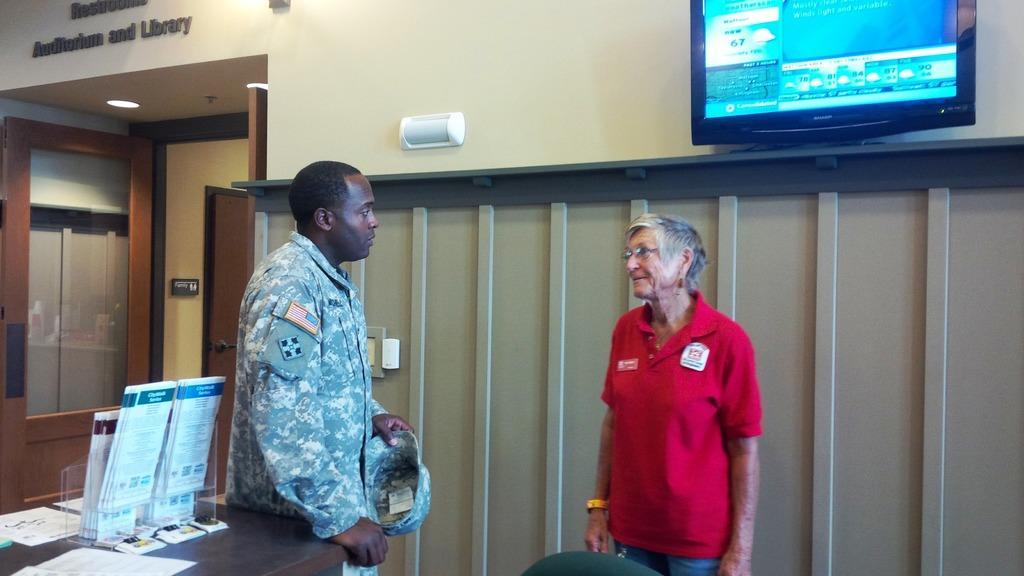Please provide a concise description of this image. In this picture, the man in the uniform and the woman in red T-shirt are standing. I think both of them are talking to each other. In the left bottom of the picture, we see a table on which papers and a glass box containing papers are placed. Behind them, we see a wall on which television is placed. On the left side, we see a glass door and a wall on which "Auditorium and Library" is written. 